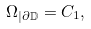<formula> <loc_0><loc_0><loc_500><loc_500>\Omega _ { | \partial { \mathbb { D } } } = C _ { 1 } ,</formula> 